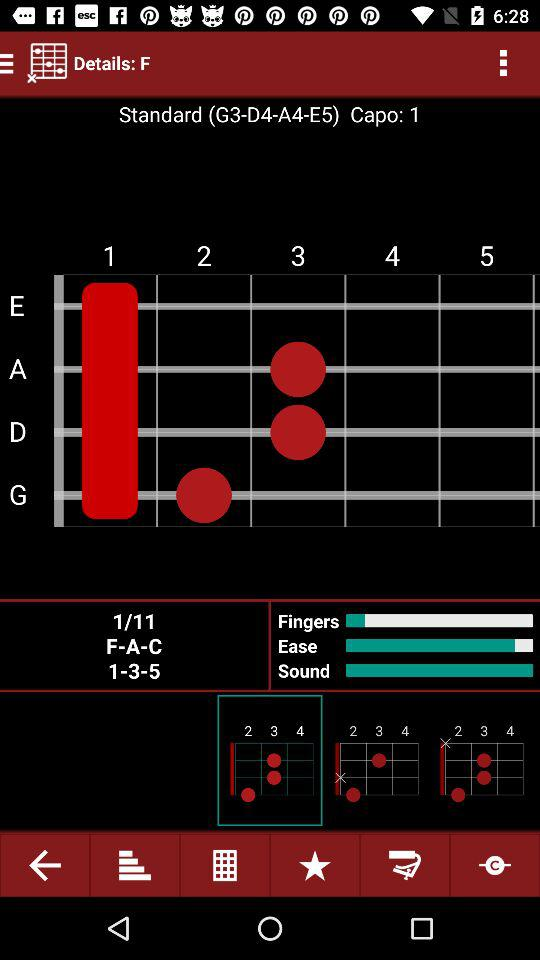What's the capo? The capo is 1. 